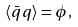Convert formula to latex. <formula><loc_0><loc_0><loc_500><loc_500>\langle \bar { q } q \rangle = \phi ,</formula> 